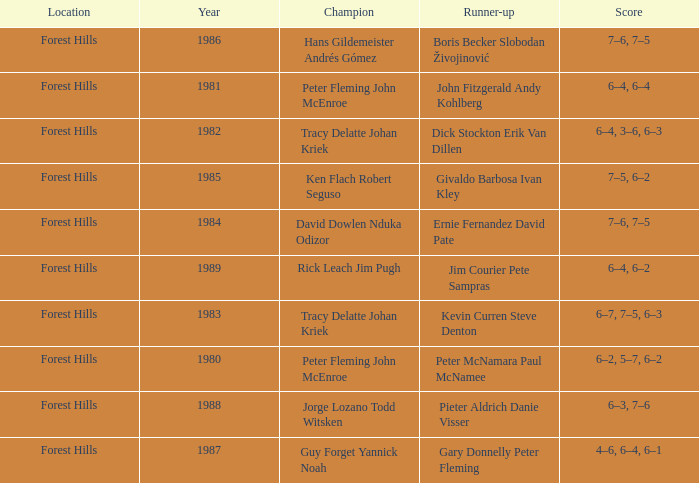Who were the champions in 1988? Jorge Lozano Todd Witsken. 